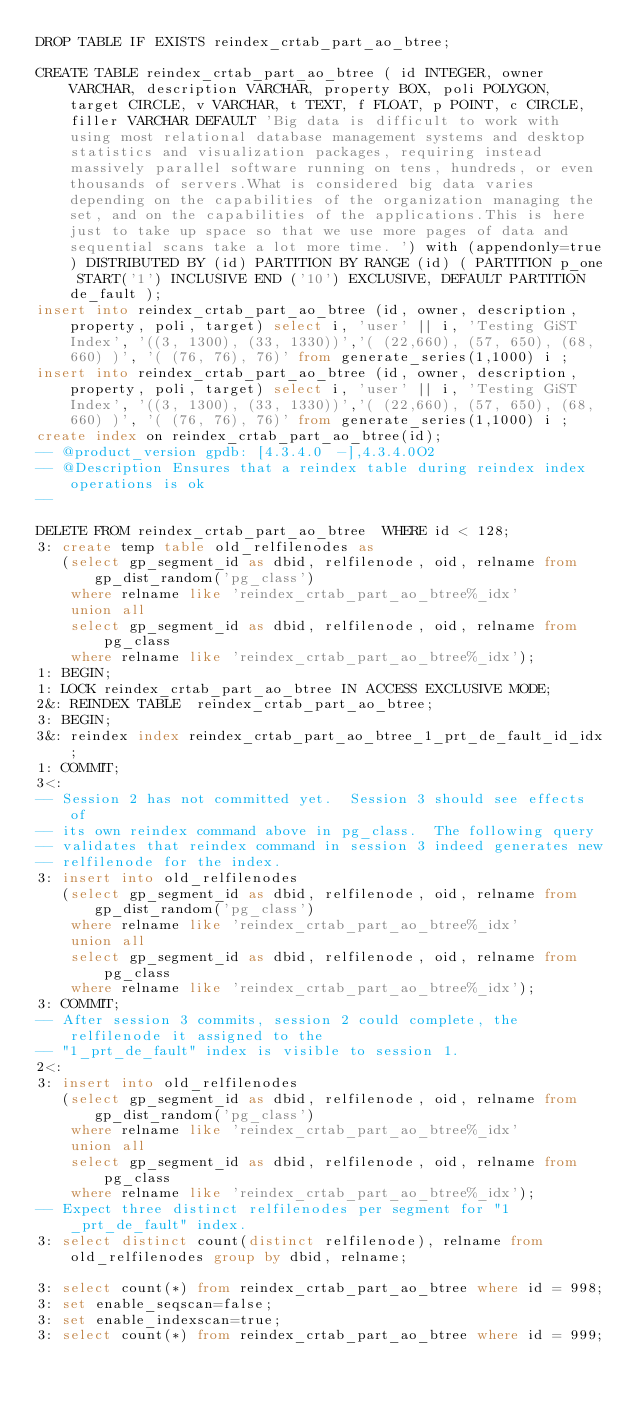<code> <loc_0><loc_0><loc_500><loc_500><_SQL_>DROP TABLE IF EXISTS reindex_crtab_part_ao_btree;

CREATE TABLE reindex_crtab_part_ao_btree ( id INTEGER, owner VARCHAR, description VARCHAR, property BOX, poli POLYGON, target CIRCLE, v VARCHAR, t TEXT, f FLOAT, p POINT, c CIRCLE, filler VARCHAR DEFAULT 'Big data is difficult to work with using most relational database management systems and desktop statistics and visualization packages, requiring instead massively parallel software running on tens, hundreds, or even thousands of servers.What is considered big data varies depending on the capabilities of the organization managing the set, and on the capabilities of the applications.This is here just to take up space so that we use more pages of data and sequential scans take a lot more time. ') with (appendonly=true) DISTRIBUTED BY (id) PARTITION BY RANGE (id) ( PARTITION p_one START('1') INCLUSIVE END ('10') EXCLUSIVE, DEFAULT PARTITION de_fault );
insert into reindex_crtab_part_ao_btree (id, owner, description, property, poli, target) select i, 'user' || i, 'Testing GiST Index', '((3, 1300), (33, 1330))','( (22,660), (57, 650), (68, 660) )', '( (76, 76), 76)' from generate_series(1,1000) i ;
insert into reindex_crtab_part_ao_btree (id, owner, description, property, poli, target) select i, 'user' || i, 'Testing GiST Index', '((3, 1300), (33, 1330))','( (22,660), (57, 650), (68, 660) )', '( (76, 76), 76)' from generate_series(1,1000) i ;
create index on reindex_crtab_part_ao_btree(id);
-- @product_version gpdb: [4.3.4.0 -],4.3.4.0O2
-- @Description Ensures that a reindex table during reindex index operations is ok
-- 

DELETE FROM reindex_crtab_part_ao_btree  WHERE id < 128;
3: create temp table old_relfilenodes as
   (select gp_segment_id as dbid, relfilenode, oid, relname from gp_dist_random('pg_class')
    where relname like 'reindex_crtab_part_ao_btree%_idx'
    union all
    select gp_segment_id as dbid, relfilenode, oid, relname from pg_class
    where relname like 'reindex_crtab_part_ao_btree%_idx');
1: BEGIN;
1: LOCK reindex_crtab_part_ao_btree IN ACCESS EXCLUSIVE MODE;
2&: REINDEX TABLE  reindex_crtab_part_ao_btree;
3: BEGIN;
3&: reindex index reindex_crtab_part_ao_btree_1_prt_de_fault_id_idx;
1: COMMIT;
3<:
-- Session 2 has not committed yet.  Session 3 should see effects of
-- its own reindex command above in pg_class.  The following query
-- validates that reindex command in session 3 indeed generates new
-- relfilenode for the index.
3: insert into old_relfilenodes
   (select gp_segment_id as dbid, relfilenode, oid, relname from gp_dist_random('pg_class')
    where relname like 'reindex_crtab_part_ao_btree%_idx'
    union all
    select gp_segment_id as dbid, relfilenode, oid, relname from pg_class
    where relname like 'reindex_crtab_part_ao_btree%_idx');
3: COMMIT;
-- After session 3 commits, session 2 could complete, the relfilenode it assigned to the
-- "1_prt_de_fault" index is visible to session 1.
2<:
3: insert into old_relfilenodes
   (select gp_segment_id as dbid, relfilenode, oid, relname from gp_dist_random('pg_class')
    where relname like 'reindex_crtab_part_ao_btree%_idx'
    union all
    select gp_segment_id as dbid, relfilenode, oid, relname from pg_class
    where relname like 'reindex_crtab_part_ao_btree%_idx');
-- Expect three distinct relfilenodes per segment for "1_prt_de_fault" index.
3: select distinct count(distinct relfilenode), relname from old_relfilenodes group by dbid, relname;

3: select count(*) from reindex_crtab_part_ao_btree where id = 998;
3: set enable_seqscan=false;
3: set enable_indexscan=true;
3: select count(*) from reindex_crtab_part_ao_btree where id = 999;
</code> 